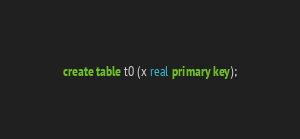<code> <loc_0><loc_0><loc_500><loc_500><_SQL_>create table t0 (x real primary key);
</code> 